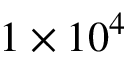Convert formula to latex. <formula><loc_0><loc_0><loc_500><loc_500>1 \times 1 0 ^ { 4 }</formula> 